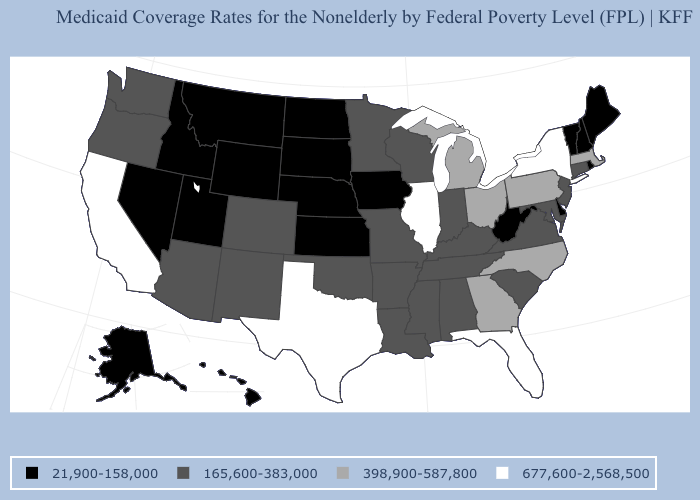Name the states that have a value in the range 165,600-383,000?
Write a very short answer. Alabama, Arizona, Arkansas, Colorado, Connecticut, Indiana, Kentucky, Louisiana, Maryland, Minnesota, Mississippi, Missouri, New Jersey, New Mexico, Oklahoma, Oregon, South Carolina, Tennessee, Virginia, Washington, Wisconsin. Among the states that border Michigan , does Indiana have the lowest value?
Answer briefly. Yes. Is the legend a continuous bar?
Give a very brief answer. No. What is the highest value in states that border Massachusetts?
Write a very short answer. 677,600-2,568,500. What is the value of West Virginia?
Give a very brief answer. 21,900-158,000. Name the states that have a value in the range 677,600-2,568,500?
Be succinct. California, Florida, Illinois, New York, Texas. Name the states that have a value in the range 398,900-587,800?
Short answer required. Georgia, Massachusetts, Michigan, North Carolina, Ohio, Pennsylvania. Among the states that border Arkansas , does Texas have the highest value?
Give a very brief answer. Yes. What is the value of Colorado?
Short answer required. 165,600-383,000. Which states have the highest value in the USA?
Be succinct. California, Florida, Illinois, New York, Texas. What is the highest value in the USA?
Give a very brief answer. 677,600-2,568,500. Is the legend a continuous bar?
Concise answer only. No. What is the highest value in the USA?
Give a very brief answer. 677,600-2,568,500. What is the value of Pennsylvania?
Write a very short answer. 398,900-587,800. What is the highest value in the MidWest ?
Concise answer only. 677,600-2,568,500. 